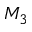Convert formula to latex. <formula><loc_0><loc_0><loc_500><loc_500>M _ { 3 }</formula> 